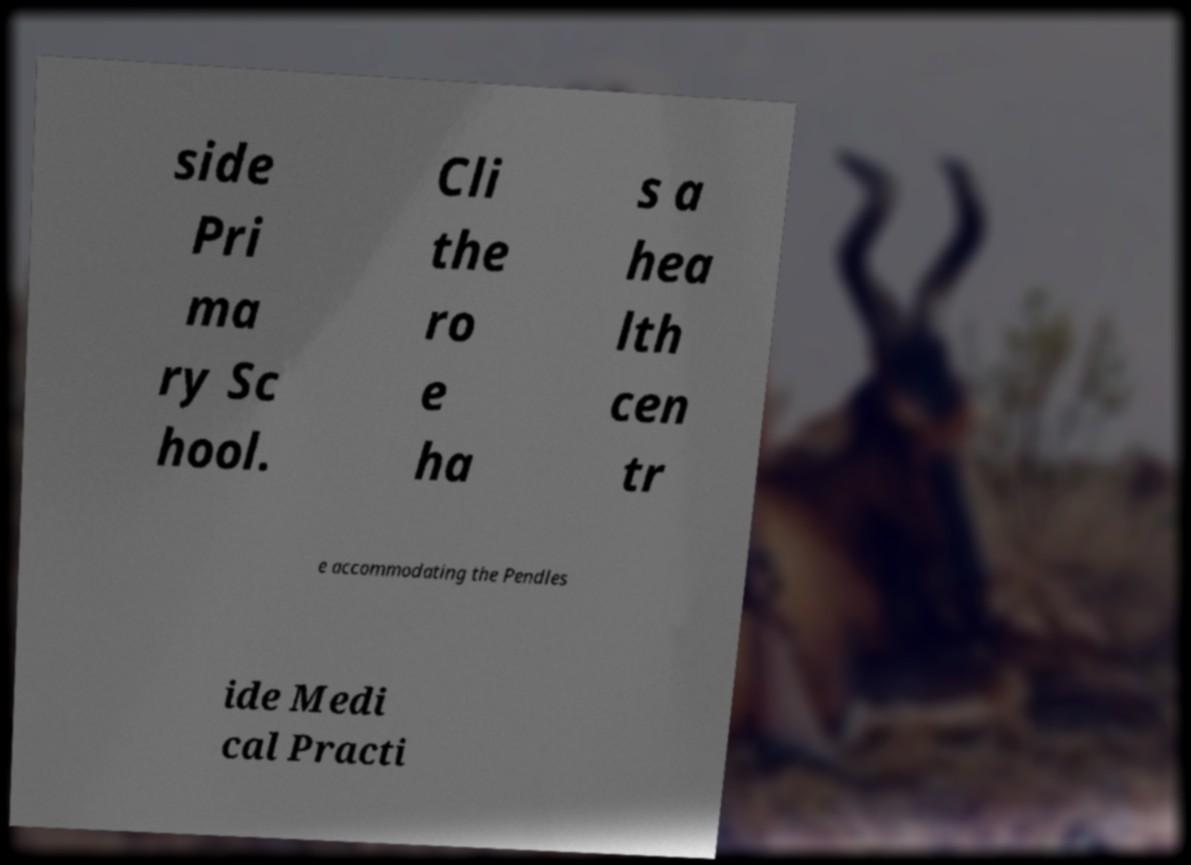I need the written content from this picture converted into text. Can you do that? side Pri ma ry Sc hool. Cli the ro e ha s a hea lth cen tr e accommodating the Pendles ide Medi cal Practi 